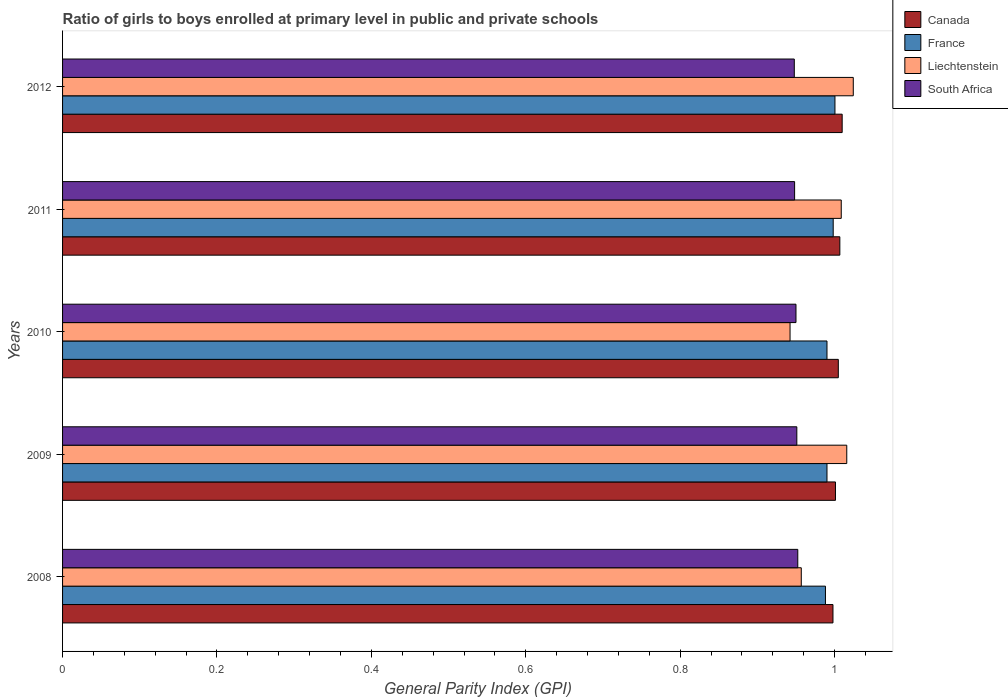How many different coloured bars are there?
Your response must be concise. 4. How many groups of bars are there?
Give a very brief answer. 5. In how many cases, is the number of bars for a given year not equal to the number of legend labels?
Keep it short and to the point. 0. What is the general parity index in France in 2011?
Your response must be concise. 1. Across all years, what is the maximum general parity index in South Africa?
Your response must be concise. 0.95. Across all years, what is the minimum general parity index in France?
Offer a terse response. 0.99. What is the total general parity index in France in the graph?
Offer a very short reply. 4.97. What is the difference between the general parity index in France in 2008 and that in 2012?
Your response must be concise. -0.01. What is the difference between the general parity index in France in 2010 and the general parity index in Liechtenstein in 2008?
Provide a succinct answer. 0.03. What is the average general parity index in Canada per year?
Offer a terse response. 1. In the year 2009, what is the difference between the general parity index in Canada and general parity index in Liechtenstein?
Your answer should be very brief. -0.01. In how many years, is the general parity index in Liechtenstein greater than 0.8 ?
Keep it short and to the point. 5. What is the ratio of the general parity index in Liechtenstein in 2010 to that in 2011?
Keep it short and to the point. 0.93. What is the difference between the highest and the second highest general parity index in South Africa?
Your answer should be very brief. 0. What is the difference between the highest and the lowest general parity index in France?
Provide a short and direct response. 0.01. Is it the case that in every year, the sum of the general parity index in South Africa and general parity index in Canada is greater than the sum of general parity index in Liechtenstein and general parity index in France?
Keep it short and to the point. No. What does the 1st bar from the top in 2011 represents?
Give a very brief answer. South Africa. What is the title of the graph?
Keep it short and to the point. Ratio of girls to boys enrolled at primary level in public and private schools. What is the label or title of the X-axis?
Keep it short and to the point. General Parity Index (GPI). What is the General Parity Index (GPI) of Canada in 2008?
Keep it short and to the point. 1. What is the General Parity Index (GPI) of France in 2008?
Offer a terse response. 0.99. What is the General Parity Index (GPI) in Liechtenstein in 2008?
Your answer should be compact. 0.96. What is the General Parity Index (GPI) in South Africa in 2008?
Provide a short and direct response. 0.95. What is the General Parity Index (GPI) of Canada in 2009?
Provide a succinct answer. 1. What is the General Parity Index (GPI) of France in 2009?
Offer a terse response. 0.99. What is the General Parity Index (GPI) of Liechtenstein in 2009?
Keep it short and to the point. 1.02. What is the General Parity Index (GPI) of South Africa in 2009?
Offer a very short reply. 0.95. What is the General Parity Index (GPI) of Canada in 2010?
Give a very brief answer. 1. What is the General Parity Index (GPI) of France in 2010?
Your response must be concise. 0.99. What is the General Parity Index (GPI) of Liechtenstein in 2010?
Offer a terse response. 0.94. What is the General Parity Index (GPI) of South Africa in 2010?
Your answer should be very brief. 0.95. What is the General Parity Index (GPI) of Canada in 2011?
Your answer should be compact. 1.01. What is the General Parity Index (GPI) of France in 2011?
Give a very brief answer. 1. What is the General Parity Index (GPI) of Liechtenstein in 2011?
Provide a succinct answer. 1.01. What is the General Parity Index (GPI) in South Africa in 2011?
Offer a terse response. 0.95. What is the General Parity Index (GPI) of Canada in 2012?
Your answer should be very brief. 1.01. What is the General Parity Index (GPI) of France in 2012?
Your answer should be compact. 1. What is the General Parity Index (GPI) in Liechtenstein in 2012?
Ensure brevity in your answer.  1.02. What is the General Parity Index (GPI) in South Africa in 2012?
Offer a very short reply. 0.95. Across all years, what is the maximum General Parity Index (GPI) of Canada?
Ensure brevity in your answer.  1.01. Across all years, what is the maximum General Parity Index (GPI) in France?
Give a very brief answer. 1. Across all years, what is the maximum General Parity Index (GPI) of Liechtenstein?
Ensure brevity in your answer.  1.02. Across all years, what is the maximum General Parity Index (GPI) of South Africa?
Make the answer very short. 0.95. Across all years, what is the minimum General Parity Index (GPI) of Canada?
Make the answer very short. 1. Across all years, what is the minimum General Parity Index (GPI) of France?
Keep it short and to the point. 0.99. Across all years, what is the minimum General Parity Index (GPI) in Liechtenstein?
Provide a short and direct response. 0.94. Across all years, what is the minimum General Parity Index (GPI) of South Africa?
Your answer should be compact. 0.95. What is the total General Parity Index (GPI) of Canada in the graph?
Ensure brevity in your answer.  5.02. What is the total General Parity Index (GPI) of France in the graph?
Your response must be concise. 4.97. What is the total General Parity Index (GPI) in Liechtenstein in the graph?
Your answer should be compact. 4.95. What is the total General Parity Index (GPI) in South Africa in the graph?
Your answer should be very brief. 4.75. What is the difference between the General Parity Index (GPI) in Canada in 2008 and that in 2009?
Provide a short and direct response. -0. What is the difference between the General Parity Index (GPI) of France in 2008 and that in 2009?
Make the answer very short. -0. What is the difference between the General Parity Index (GPI) of Liechtenstein in 2008 and that in 2009?
Ensure brevity in your answer.  -0.06. What is the difference between the General Parity Index (GPI) of South Africa in 2008 and that in 2009?
Make the answer very short. 0. What is the difference between the General Parity Index (GPI) in Canada in 2008 and that in 2010?
Your response must be concise. -0.01. What is the difference between the General Parity Index (GPI) in France in 2008 and that in 2010?
Your response must be concise. -0. What is the difference between the General Parity Index (GPI) in Liechtenstein in 2008 and that in 2010?
Make the answer very short. 0.01. What is the difference between the General Parity Index (GPI) in South Africa in 2008 and that in 2010?
Provide a succinct answer. 0. What is the difference between the General Parity Index (GPI) of Canada in 2008 and that in 2011?
Make the answer very short. -0.01. What is the difference between the General Parity Index (GPI) in France in 2008 and that in 2011?
Your answer should be very brief. -0.01. What is the difference between the General Parity Index (GPI) of Liechtenstein in 2008 and that in 2011?
Ensure brevity in your answer.  -0.05. What is the difference between the General Parity Index (GPI) in South Africa in 2008 and that in 2011?
Your answer should be very brief. 0. What is the difference between the General Parity Index (GPI) of Canada in 2008 and that in 2012?
Your answer should be compact. -0.01. What is the difference between the General Parity Index (GPI) of France in 2008 and that in 2012?
Provide a short and direct response. -0.01. What is the difference between the General Parity Index (GPI) of Liechtenstein in 2008 and that in 2012?
Ensure brevity in your answer.  -0.07. What is the difference between the General Parity Index (GPI) of South Africa in 2008 and that in 2012?
Your answer should be compact. 0. What is the difference between the General Parity Index (GPI) in Canada in 2009 and that in 2010?
Ensure brevity in your answer.  -0. What is the difference between the General Parity Index (GPI) of France in 2009 and that in 2010?
Your response must be concise. 0. What is the difference between the General Parity Index (GPI) of Liechtenstein in 2009 and that in 2010?
Your response must be concise. 0.07. What is the difference between the General Parity Index (GPI) of South Africa in 2009 and that in 2010?
Your answer should be compact. 0. What is the difference between the General Parity Index (GPI) in Canada in 2009 and that in 2011?
Your answer should be compact. -0.01. What is the difference between the General Parity Index (GPI) of France in 2009 and that in 2011?
Keep it short and to the point. -0.01. What is the difference between the General Parity Index (GPI) in Liechtenstein in 2009 and that in 2011?
Your answer should be compact. 0.01. What is the difference between the General Parity Index (GPI) in South Africa in 2009 and that in 2011?
Make the answer very short. 0. What is the difference between the General Parity Index (GPI) in Canada in 2009 and that in 2012?
Give a very brief answer. -0.01. What is the difference between the General Parity Index (GPI) of France in 2009 and that in 2012?
Keep it short and to the point. -0.01. What is the difference between the General Parity Index (GPI) in Liechtenstein in 2009 and that in 2012?
Your answer should be compact. -0.01. What is the difference between the General Parity Index (GPI) of South Africa in 2009 and that in 2012?
Give a very brief answer. 0. What is the difference between the General Parity Index (GPI) of Canada in 2010 and that in 2011?
Provide a short and direct response. -0. What is the difference between the General Parity Index (GPI) of France in 2010 and that in 2011?
Provide a succinct answer. -0.01. What is the difference between the General Parity Index (GPI) in Liechtenstein in 2010 and that in 2011?
Provide a succinct answer. -0.07. What is the difference between the General Parity Index (GPI) of South Africa in 2010 and that in 2011?
Provide a short and direct response. 0. What is the difference between the General Parity Index (GPI) in Canada in 2010 and that in 2012?
Provide a succinct answer. -0.01. What is the difference between the General Parity Index (GPI) in France in 2010 and that in 2012?
Keep it short and to the point. -0.01. What is the difference between the General Parity Index (GPI) in Liechtenstein in 2010 and that in 2012?
Keep it short and to the point. -0.08. What is the difference between the General Parity Index (GPI) in South Africa in 2010 and that in 2012?
Make the answer very short. 0. What is the difference between the General Parity Index (GPI) of Canada in 2011 and that in 2012?
Ensure brevity in your answer.  -0. What is the difference between the General Parity Index (GPI) of France in 2011 and that in 2012?
Offer a terse response. -0. What is the difference between the General Parity Index (GPI) of Liechtenstein in 2011 and that in 2012?
Make the answer very short. -0.02. What is the difference between the General Parity Index (GPI) of Canada in 2008 and the General Parity Index (GPI) of France in 2009?
Give a very brief answer. 0.01. What is the difference between the General Parity Index (GPI) of Canada in 2008 and the General Parity Index (GPI) of Liechtenstein in 2009?
Your answer should be compact. -0.02. What is the difference between the General Parity Index (GPI) in Canada in 2008 and the General Parity Index (GPI) in South Africa in 2009?
Your response must be concise. 0.05. What is the difference between the General Parity Index (GPI) in France in 2008 and the General Parity Index (GPI) in Liechtenstein in 2009?
Your answer should be very brief. -0.03. What is the difference between the General Parity Index (GPI) in France in 2008 and the General Parity Index (GPI) in South Africa in 2009?
Provide a short and direct response. 0.04. What is the difference between the General Parity Index (GPI) of Liechtenstein in 2008 and the General Parity Index (GPI) of South Africa in 2009?
Ensure brevity in your answer.  0.01. What is the difference between the General Parity Index (GPI) of Canada in 2008 and the General Parity Index (GPI) of France in 2010?
Your answer should be very brief. 0.01. What is the difference between the General Parity Index (GPI) of Canada in 2008 and the General Parity Index (GPI) of Liechtenstein in 2010?
Make the answer very short. 0.06. What is the difference between the General Parity Index (GPI) of Canada in 2008 and the General Parity Index (GPI) of South Africa in 2010?
Keep it short and to the point. 0.05. What is the difference between the General Parity Index (GPI) of France in 2008 and the General Parity Index (GPI) of Liechtenstein in 2010?
Ensure brevity in your answer.  0.05. What is the difference between the General Parity Index (GPI) of France in 2008 and the General Parity Index (GPI) of South Africa in 2010?
Ensure brevity in your answer.  0.04. What is the difference between the General Parity Index (GPI) in Liechtenstein in 2008 and the General Parity Index (GPI) in South Africa in 2010?
Offer a very short reply. 0.01. What is the difference between the General Parity Index (GPI) of Canada in 2008 and the General Parity Index (GPI) of France in 2011?
Offer a very short reply. -0. What is the difference between the General Parity Index (GPI) in Canada in 2008 and the General Parity Index (GPI) in Liechtenstein in 2011?
Your response must be concise. -0.01. What is the difference between the General Parity Index (GPI) of Canada in 2008 and the General Parity Index (GPI) of South Africa in 2011?
Ensure brevity in your answer.  0.05. What is the difference between the General Parity Index (GPI) in France in 2008 and the General Parity Index (GPI) in Liechtenstein in 2011?
Make the answer very short. -0.02. What is the difference between the General Parity Index (GPI) of France in 2008 and the General Parity Index (GPI) of South Africa in 2011?
Offer a terse response. 0.04. What is the difference between the General Parity Index (GPI) of Liechtenstein in 2008 and the General Parity Index (GPI) of South Africa in 2011?
Your answer should be very brief. 0.01. What is the difference between the General Parity Index (GPI) in Canada in 2008 and the General Parity Index (GPI) in France in 2012?
Keep it short and to the point. -0. What is the difference between the General Parity Index (GPI) of Canada in 2008 and the General Parity Index (GPI) of Liechtenstein in 2012?
Give a very brief answer. -0.03. What is the difference between the General Parity Index (GPI) in Canada in 2008 and the General Parity Index (GPI) in South Africa in 2012?
Give a very brief answer. 0.05. What is the difference between the General Parity Index (GPI) of France in 2008 and the General Parity Index (GPI) of Liechtenstein in 2012?
Offer a terse response. -0.04. What is the difference between the General Parity Index (GPI) in France in 2008 and the General Parity Index (GPI) in South Africa in 2012?
Your answer should be compact. 0.04. What is the difference between the General Parity Index (GPI) of Liechtenstein in 2008 and the General Parity Index (GPI) of South Africa in 2012?
Provide a short and direct response. 0.01. What is the difference between the General Parity Index (GPI) of Canada in 2009 and the General Parity Index (GPI) of France in 2010?
Provide a succinct answer. 0.01. What is the difference between the General Parity Index (GPI) in Canada in 2009 and the General Parity Index (GPI) in Liechtenstein in 2010?
Ensure brevity in your answer.  0.06. What is the difference between the General Parity Index (GPI) in Canada in 2009 and the General Parity Index (GPI) in South Africa in 2010?
Make the answer very short. 0.05. What is the difference between the General Parity Index (GPI) in France in 2009 and the General Parity Index (GPI) in Liechtenstein in 2010?
Your answer should be compact. 0.05. What is the difference between the General Parity Index (GPI) of France in 2009 and the General Parity Index (GPI) of South Africa in 2010?
Give a very brief answer. 0.04. What is the difference between the General Parity Index (GPI) of Liechtenstein in 2009 and the General Parity Index (GPI) of South Africa in 2010?
Ensure brevity in your answer.  0.07. What is the difference between the General Parity Index (GPI) of Canada in 2009 and the General Parity Index (GPI) of France in 2011?
Make the answer very short. 0. What is the difference between the General Parity Index (GPI) in Canada in 2009 and the General Parity Index (GPI) in Liechtenstein in 2011?
Make the answer very short. -0.01. What is the difference between the General Parity Index (GPI) of Canada in 2009 and the General Parity Index (GPI) of South Africa in 2011?
Provide a short and direct response. 0.05. What is the difference between the General Parity Index (GPI) in France in 2009 and the General Parity Index (GPI) in Liechtenstein in 2011?
Provide a short and direct response. -0.02. What is the difference between the General Parity Index (GPI) of France in 2009 and the General Parity Index (GPI) of South Africa in 2011?
Give a very brief answer. 0.04. What is the difference between the General Parity Index (GPI) of Liechtenstein in 2009 and the General Parity Index (GPI) of South Africa in 2011?
Make the answer very short. 0.07. What is the difference between the General Parity Index (GPI) in Canada in 2009 and the General Parity Index (GPI) in France in 2012?
Offer a terse response. 0. What is the difference between the General Parity Index (GPI) of Canada in 2009 and the General Parity Index (GPI) of Liechtenstein in 2012?
Give a very brief answer. -0.02. What is the difference between the General Parity Index (GPI) of Canada in 2009 and the General Parity Index (GPI) of South Africa in 2012?
Ensure brevity in your answer.  0.05. What is the difference between the General Parity Index (GPI) of France in 2009 and the General Parity Index (GPI) of Liechtenstein in 2012?
Your answer should be very brief. -0.03. What is the difference between the General Parity Index (GPI) in France in 2009 and the General Parity Index (GPI) in South Africa in 2012?
Keep it short and to the point. 0.04. What is the difference between the General Parity Index (GPI) of Liechtenstein in 2009 and the General Parity Index (GPI) of South Africa in 2012?
Give a very brief answer. 0.07. What is the difference between the General Parity Index (GPI) of Canada in 2010 and the General Parity Index (GPI) of France in 2011?
Ensure brevity in your answer.  0.01. What is the difference between the General Parity Index (GPI) in Canada in 2010 and the General Parity Index (GPI) in Liechtenstein in 2011?
Give a very brief answer. -0. What is the difference between the General Parity Index (GPI) in Canada in 2010 and the General Parity Index (GPI) in South Africa in 2011?
Keep it short and to the point. 0.06. What is the difference between the General Parity Index (GPI) of France in 2010 and the General Parity Index (GPI) of Liechtenstein in 2011?
Give a very brief answer. -0.02. What is the difference between the General Parity Index (GPI) in France in 2010 and the General Parity Index (GPI) in South Africa in 2011?
Ensure brevity in your answer.  0.04. What is the difference between the General Parity Index (GPI) in Liechtenstein in 2010 and the General Parity Index (GPI) in South Africa in 2011?
Make the answer very short. -0.01. What is the difference between the General Parity Index (GPI) in Canada in 2010 and the General Parity Index (GPI) in France in 2012?
Your answer should be very brief. 0. What is the difference between the General Parity Index (GPI) in Canada in 2010 and the General Parity Index (GPI) in Liechtenstein in 2012?
Offer a terse response. -0.02. What is the difference between the General Parity Index (GPI) of Canada in 2010 and the General Parity Index (GPI) of South Africa in 2012?
Provide a succinct answer. 0.06. What is the difference between the General Parity Index (GPI) of France in 2010 and the General Parity Index (GPI) of Liechtenstein in 2012?
Keep it short and to the point. -0.03. What is the difference between the General Parity Index (GPI) in France in 2010 and the General Parity Index (GPI) in South Africa in 2012?
Provide a short and direct response. 0.04. What is the difference between the General Parity Index (GPI) in Liechtenstein in 2010 and the General Parity Index (GPI) in South Africa in 2012?
Offer a very short reply. -0.01. What is the difference between the General Parity Index (GPI) in Canada in 2011 and the General Parity Index (GPI) in France in 2012?
Your answer should be very brief. 0.01. What is the difference between the General Parity Index (GPI) in Canada in 2011 and the General Parity Index (GPI) in Liechtenstein in 2012?
Give a very brief answer. -0.02. What is the difference between the General Parity Index (GPI) of Canada in 2011 and the General Parity Index (GPI) of South Africa in 2012?
Give a very brief answer. 0.06. What is the difference between the General Parity Index (GPI) in France in 2011 and the General Parity Index (GPI) in Liechtenstein in 2012?
Provide a short and direct response. -0.03. What is the difference between the General Parity Index (GPI) in France in 2011 and the General Parity Index (GPI) in South Africa in 2012?
Ensure brevity in your answer.  0.05. What is the difference between the General Parity Index (GPI) in Liechtenstein in 2011 and the General Parity Index (GPI) in South Africa in 2012?
Offer a terse response. 0.06. What is the average General Parity Index (GPI) in Canada per year?
Provide a short and direct response. 1. What is the average General Parity Index (GPI) in Liechtenstein per year?
Your answer should be compact. 0.99. What is the average General Parity Index (GPI) in South Africa per year?
Ensure brevity in your answer.  0.95. In the year 2008, what is the difference between the General Parity Index (GPI) in Canada and General Parity Index (GPI) in France?
Your answer should be compact. 0.01. In the year 2008, what is the difference between the General Parity Index (GPI) of Canada and General Parity Index (GPI) of Liechtenstein?
Your response must be concise. 0.04. In the year 2008, what is the difference between the General Parity Index (GPI) in Canada and General Parity Index (GPI) in South Africa?
Keep it short and to the point. 0.05. In the year 2008, what is the difference between the General Parity Index (GPI) in France and General Parity Index (GPI) in Liechtenstein?
Make the answer very short. 0.03. In the year 2008, what is the difference between the General Parity Index (GPI) in France and General Parity Index (GPI) in South Africa?
Provide a succinct answer. 0.04. In the year 2008, what is the difference between the General Parity Index (GPI) of Liechtenstein and General Parity Index (GPI) of South Africa?
Ensure brevity in your answer.  0. In the year 2009, what is the difference between the General Parity Index (GPI) of Canada and General Parity Index (GPI) of France?
Make the answer very short. 0.01. In the year 2009, what is the difference between the General Parity Index (GPI) of Canada and General Parity Index (GPI) of Liechtenstein?
Your answer should be compact. -0.01. In the year 2009, what is the difference between the General Parity Index (GPI) of Canada and General Parity Index (GPI) of South Africa?
Make the answer very short. 0.05. In the year 2009, what is the difference between the General Parity Index (GPI) of France and General Parity Index (GPI) of Liechtenstein?
Your answer should be compact. -0.03. In the year 2009, what is the difference between the General Parity Index (GPI) in France and General Parity Index (GPI) in South Africa?
Keep it short and to the point. 0.04. In the year 2009, what is the difference between the General Parity Index (GPI) in Liechtenstein and General Parity Index (GPI) in South Africa?
Your response must be concise. 0.06. In the year 2010, what is the difference between the General Parity Index (GPI) of Canada and General Parity Index (GPI) of France?
Offer a terse response. 0.01. In the year 2010, what is the difference between the General Parity Index (GPI) of Canada and General Parity Index (GPI) of Liechtenstein?
Provide a short and direct response. 0.06. In the year 2010, what is the difference between the General Parity Index (GPI) in Canada and General Parity Index (GPI) in South Africa?
Your answer should be compact. 0.05. In the year 2010, what is the difference between the General Parity Index (GPI) in France and General Parity Index (GPI) in Liechtenstein?
Provide a succinct answer. 0.05. In the year 2010, what is the difference between the General Parity Index (GPI) of France and General Parity Index (GPI) of South Africa?
Make the answer very short. 0.04. In the year 2010, what is the difference between the General Parity Index (GPI) in Liechtenstein and General Parity Index (GPI) in South Africa?
Your answer should be compact. -0.01. In the year 2011, what is the difference between the General Parity Index (GPI) of Canada and General Parity Index (GPI) of France?
Provide a short and direct response. 0.01. In the year 2011, what is the difference between the General Parity Index (GPI) of Canada and General Parity Index (GPI) of Liechtenstein?
Your response must be concise. -0. In the year 2011, what is the difference between the General Parity Index (GPI) in Canada and General Parity Index (GPI) in South Africa?
Provide a succinct answer. 0.06. In the year 2011, what is the difference between the General Parity Index (GPI) in France and General Parity Index (GPI) in Liechtenstein?
Make the answer very short. -0.01. In the year 2011, what is the difference between the General Parity Index (GPI) of Liechtenstein and General Parity Index (GPI) of South Africa?
Your answer should be very brief. 0.06. In the year 2012, what is the difference between the General Parity Index (GPI) in Canada and General Parity Index (GPI) in France?
Give a very brief answer. 0.01. In the year 2012, what is the difference between the General Parity Index (GPI) of Canada and General Parity Index (GPI) of Liechtenstein?
Keep it short and to the point. -0.01. In the year 2012, what is the difference between the General Parity Index (GPI) in Canada and General Parity Index (GPI) in South Africa?
Your answer should be very brief. 0.06. In the year 2012, what is the difference between the General Parity Index (GPI) in France and General Parity Index (GPI) in Liechtenstein?
Give a very brief answer. -0.02. In the year 2012, what is the difference between the General Parity Index (GPI) in France and General Parity Index (GPI) in South Africa?
Offer a very short reply. 0.05. In the year 2012, what is the difference between the General Parity Index (GPI) of Liechtenstein and General Parity Index (GPI) of South Africa?
Keep it short and to the point. 0.08. What is the ratio of the General Parity Index (GPI) of France in 2008 to that in 2009?
Offer a very short reply. 1. What is the ratio of the General Parity Index (GPI) in Liechtenstein in 2008 to that in 2009?
Keep it short and to the point. 0.94. What is the ratio of the General Parity Index (GPI) in South Africa in 2008 to that in 2009?
Make the answer very short. 1. What is the ratio of the General Parity Index (GPI) in Canada in 2008 to that in 2010?
Provide a succinct answer. 0.99. What is the ratio of the General Parity Index (GPI) of Liechtenstein in 2008 to that in 2010?
Provide a succinct answer. 1.02. What is the ratio of the General Parity Index (GPI) of Liechtenstein in 2008 to that in 2011?
Give a very brief answer. 0.95. What is the ratio of the General Parity Index (GPI) of South Africa in 2008 to that in 2011?
Your response must be concise. 1. What is the ratio of the General Parity Index (GPI) in France in 2008 to that in 2012?
Provide a succinct answer. 0.99. What is the ratio of the General Parity Index (GPI) in Liechtenstein in 2008 to that in 2012?
Make the answer very short. 0.93. What is the ratio of the General Parity Index (GPI) in Canada in 2009 to that in 2010?
Offer a terse response. 1. What is the ratio of the General Parity Index (GPI) in France in 2009 to that in 2010?
Offer a terse response. 1. What is the ratio of the General Parity Index (GPI) in Liechtenstein in 2009 to that in 2010?
Your answer should be very brief. 1.08. What is the ratio of the General Parity Index (GPI) in South Africa in 2009 to that in 2010?
Offer a terse response. 1. What is the ratio of the General Parity Index (GPI) of Canada in 2009 to that in 2011?
Your response must be concise. 0.99. What is the ratio of the General Parity Index (GPI) of France in 2009 to that in 2011?
Provide a succinct answer. 0.99. What is the ratio of the General Parity Index (GPI) of Liechtenstein in 2009 to that in 2011?
Your answer should be compact. 1.01. What is the ratio of the General Parity Index (GPI) of Canada in 2009 to that in 2012?
Provide a short and direct response. 0.99. What is the ratio of the General Parity Index (GPI) of Liechtenstein in 2009 to that in 2012?
Provide a succinct answer. 0.99. What is the ratio of the General Parity Index (GPI) of Canada in 2010 to that in 2011?
Your response must be concise. 1. What is the ratio of the General Parity Index (GPI) in France in 2010 to that in 2011?
Your answer should be compact. 0.99. What is the ratio of the General Parity Index (GPI) in Liechtenstein in 2010 to that in 2011?
Provide a short and direct response. 0.93. What is the ratio of the General Parity Index (GPI) in Liechtenstein in 2010 to that in 2012?
Give a very brief answer. 0.92. What is the ratio of the General Parity Index (GPI) in France in 2011 to that in 2012?
Your answer should be compact. 1. What is the ratio of the General Parity Index (GPI) in Liechtenstein in 2011 to that in 2012?
Make the answer very short. 0.98. What is the ratio of the General Parity Index (GPI) in South Africa in 2011 to that in 2012?
Offer a terse response. 1. What is the difference between the highest and the second highest General Parity Index (GPI) of Canada?
Provide a succinct answer. 0. What is the difference between the highest and the second highest General Parity Index (GPI) in France?
Offer a very short reply. 0. What is the difference between the highest and the second highest General Parity Index (GPI) in Liechtenstein?
Provide a succinct answer. 0.01. What is the difference between the highest and the second highest General Parity Index (GPI) in South Africa?
Offer a very short reply. 0. What is the difference between the highest and the lowest General Parity Index (GPI) in Canada?
Your answer should be very brief. 0.01. What is the difference between the highest and the lowest General Parity Index (GPI) in France?
Make the answer very short. 0.01. What is the difference between the highest and the lowest General Parity Index (GPI) of Liechtenstein?
Offer a terse response. 0.08. What is the difference between the highest and the lowest General Parity Index (GPI) of South Africa?
Ensure brevity in your answer.  0. 